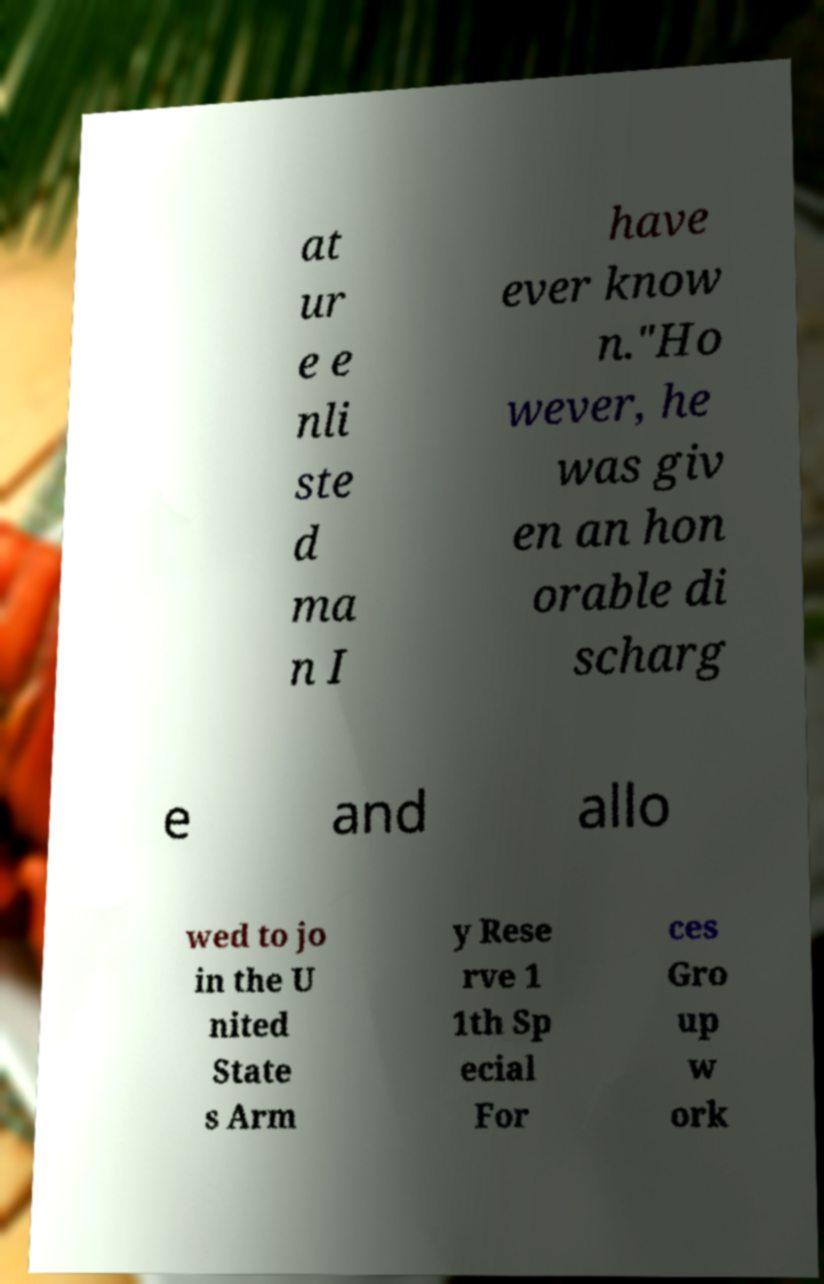Could you assist in decoding the text presented in this image and type it out clearly? at ur e e nli ste d ma n I have ever know n."Ho wever, he was giv en an hon orable di scharg e and allo wed to jo in the U nited State s Arm y Rese rve 1 1th Sp ecial For ces Gro up w ork 